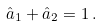<formula> <loc_0><loc_0><loc_500><loc_500>\hat { a } _ { 1 } + \hat { a } _ { 2 } = 1 \, .</formula> 